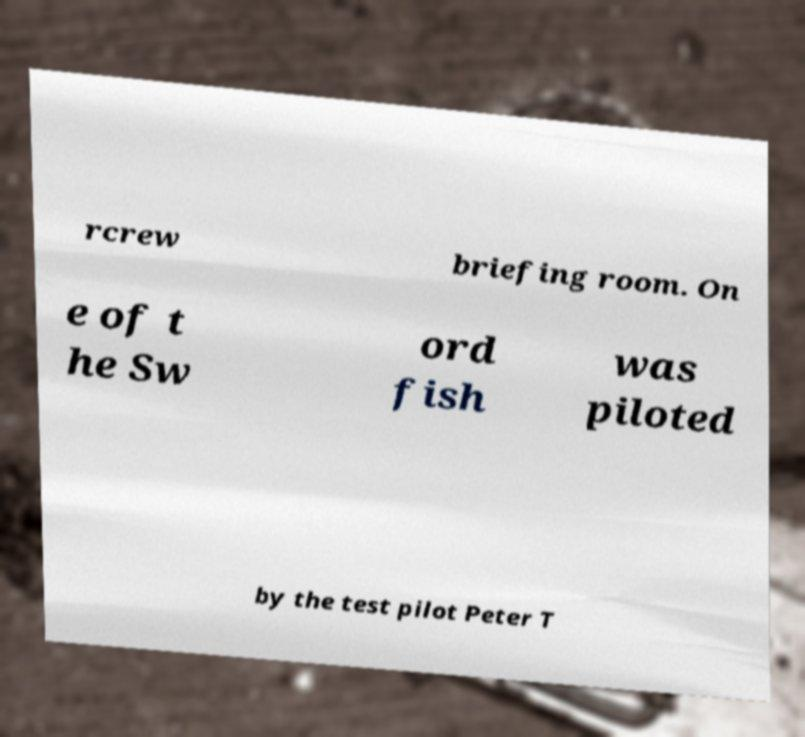What messages or text are displayed in this image? I need them in a readable, typed format. rcrew briefing room. On e of t he Sw ord fish was piloted by the test pilot Peter T 